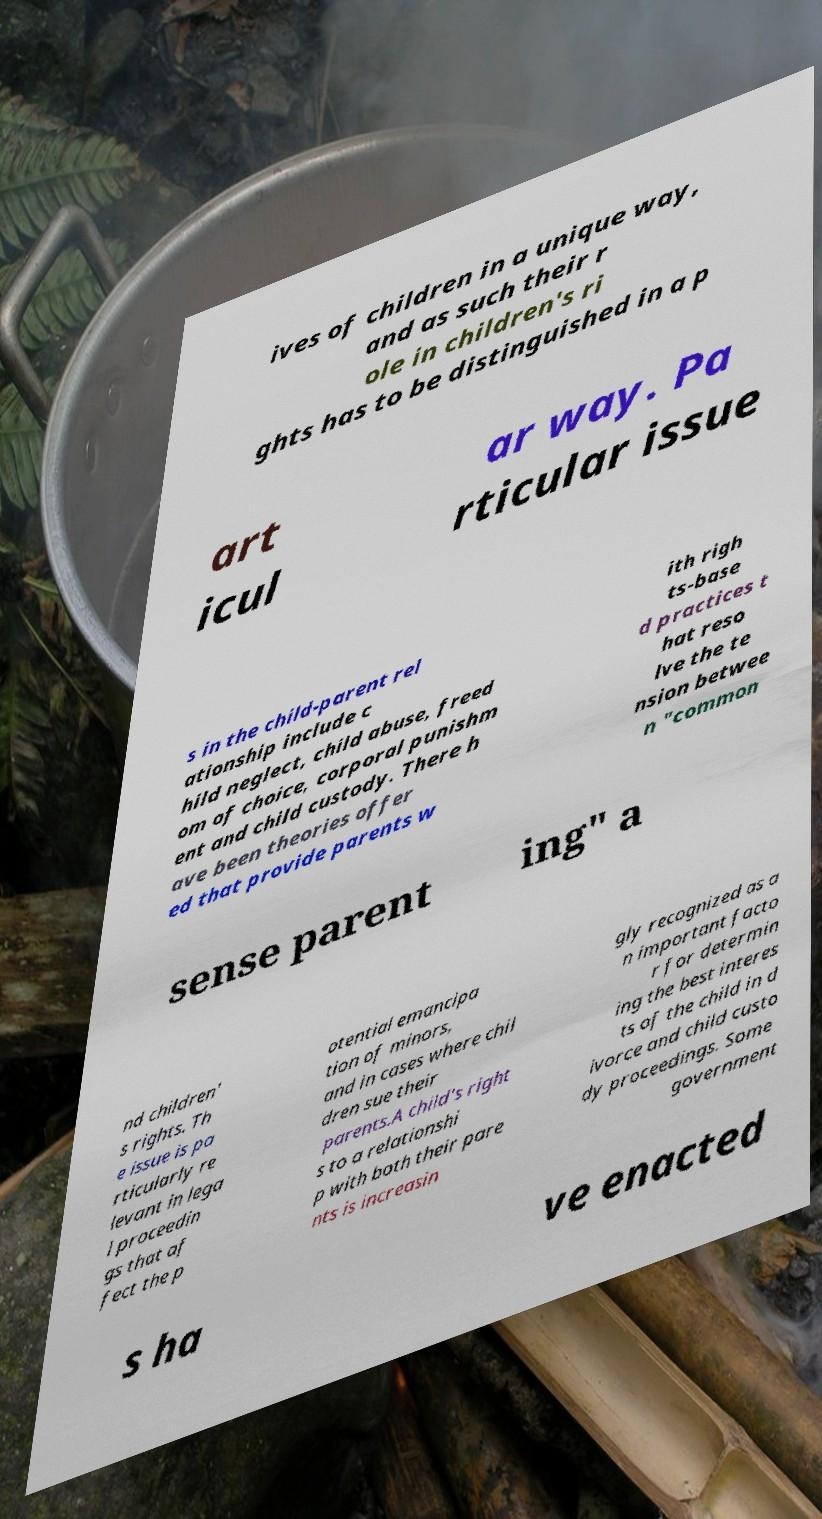Please read and relay the text visible in this image. What does it say? ives of children in a unique way, and as such their r ole in children's ri ghts has to be distinguished in a p art icul ar way. Pa rticular issue s in the child-parent rel ationship include c hild neglect, child abuse, freed om of choice, corporal punishm ent and child custody. There h ave been theories offer ed that provide parents w ith righ ts-base d practices t hat reso lve the te nsion betwee n "common sense parent ing" a nd children' s rights. Th e issue is pa rticularly re levant in lega l proceedin gs that af fect the p otential emancipa tion of minors, and in cases where chil dren sue their parents.A child's right s to a relationshi p with both their pare nts is increasin gly recognized as a n important facto r for determin ing the best interes ts of the child in d ivorce and child custo dy proceedings. Some government s ha ve enacted 